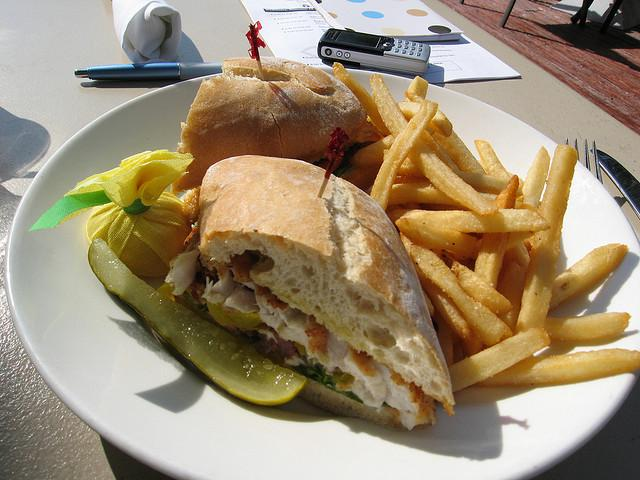Which food element here is likely most sour? pickle 